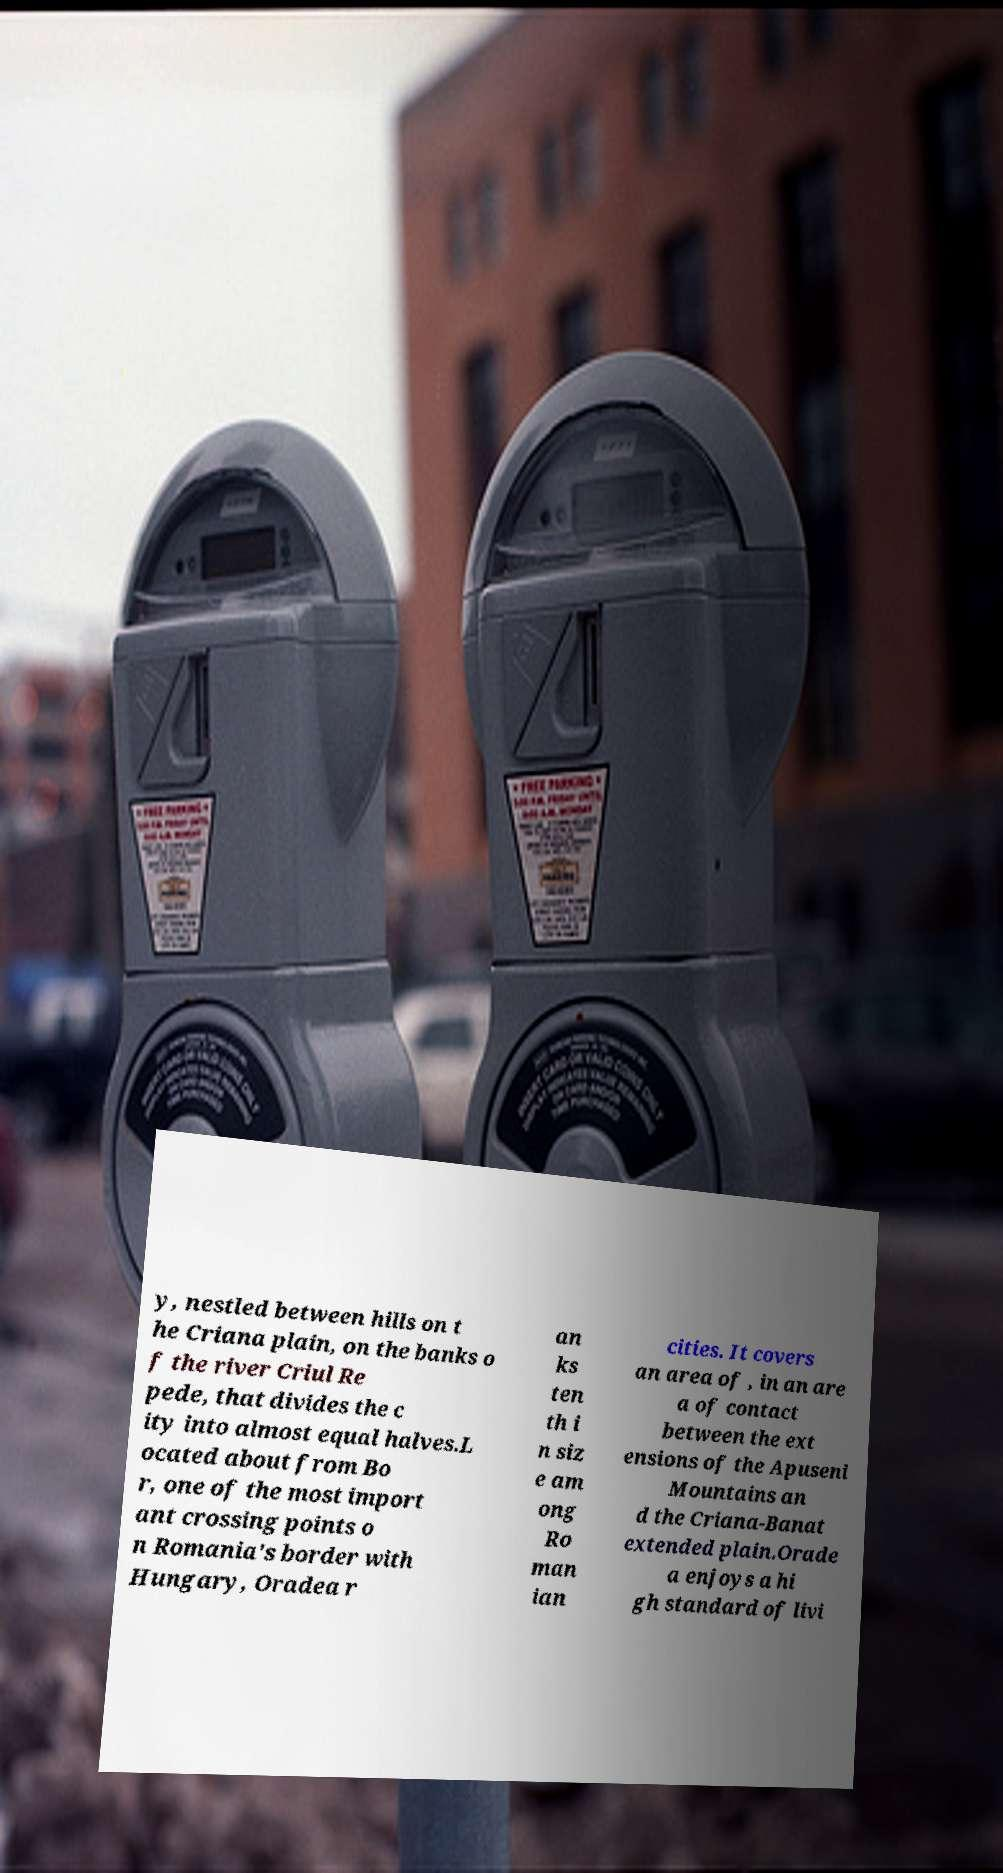Can you read and provide the text displayed in the image?This photo seems to have some interesting text. Can you extract and type it out for me? y, nestled between hills on t he Criana plain, on the banks o f the river Criul Re pede, that divides the c ity into almost equal halves.L ocated about from Bo r, one of the most import ant crossing points o n Romania's border with Hungary, Oradea r an ks ten th i n siz e am ong Ro man ian cities. It covers an area of , in an are a of contact between the ext ensions of the Apuseni Mountains an d the Criana-Banat extended plain.Orade a enjoys a hi gh standard of livi 